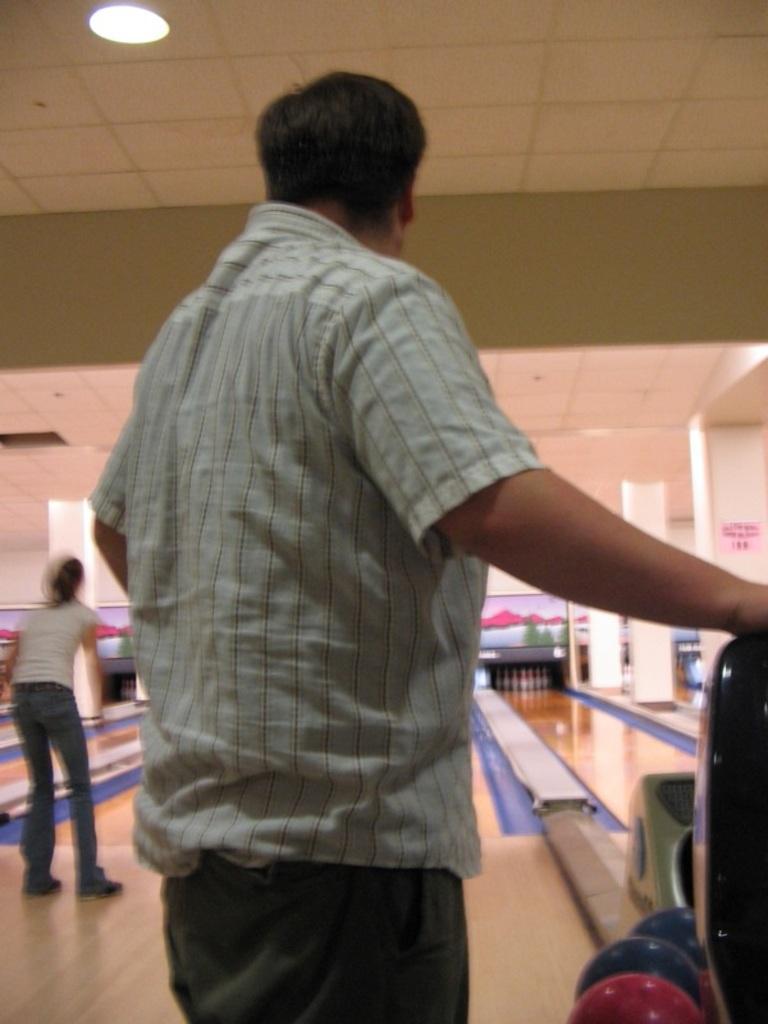How would you summarize this image in a sentence or two? In the foreground I can see two persons are playing a game on the floor. In the background I can see a wall, rooftop on which lights are mounted. This image is taken in a hall. 